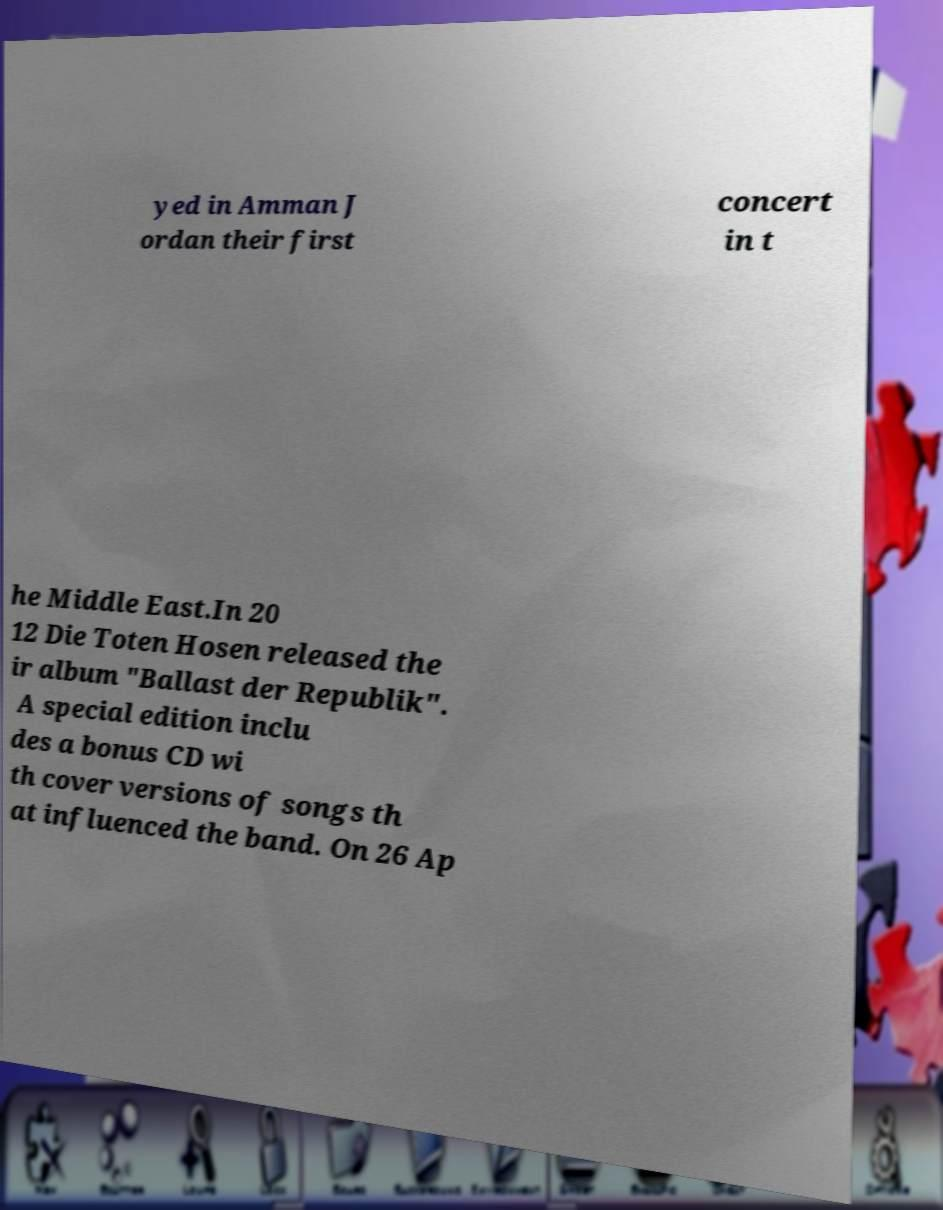For documentation purposes, I need the text within this image transcribed. Could you provide that? yed in Amman J ordan their first concert in t he Middle East.In 20 12 Die Toten Hosen released the ir album "Ballast der Republik". A special edition inclu des a bonus CD wi th cover versions of songs th at influenced the band. On 26 Ap 